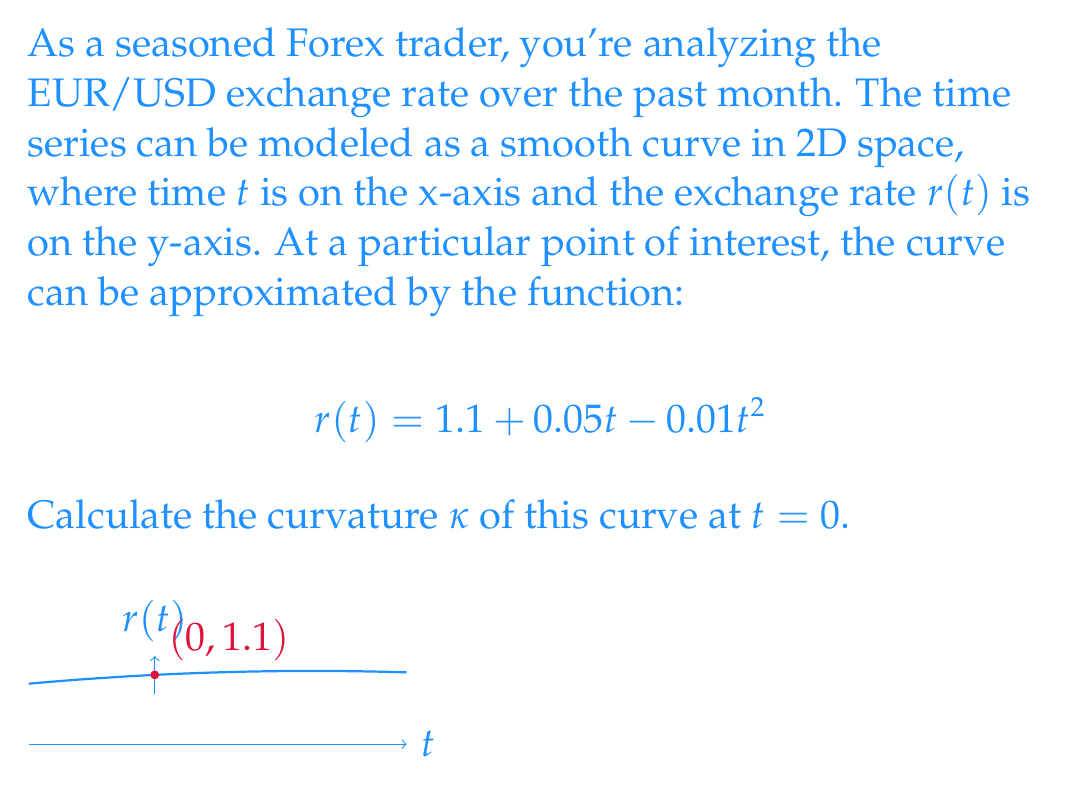Could you help me with this problem? To calculate the curvature κ of a curve y = f(x) at a point, we use the formula:

$$κ = \frac{|f''(x)|}{(1 + [f'(x)]^2)^{3/2}}$$

For our curve r(t), we need to find r'(t) and r''(t):

1) First derivative: 
   $$r'(t) = 0.05 - 0.02t$$

2) Second derivative:
   $$r''(t) = -0.02$$

3) At t = 0:
   $$r'(0) = 0.05$$
   $$r''(0) = -0.02$$

4) Now, let's substitute these values into the curvature formula:

   $$κ = \frac{|-0.02|}{(1 + [0.05]^2)^{3/2}}$$

5) Simplify:
   $$κ = \frac{0.02}{(1 + 0.0025)^{3/2}}$$

6) Calculate:
   $$κ ≈ 0.01999 ≈ 0.02$$

Therefore, the curvature of the EUR/USD exchange rate curve at t = 0 is approximately 0.02.
Answer: $κ ≈ 0.02$ 